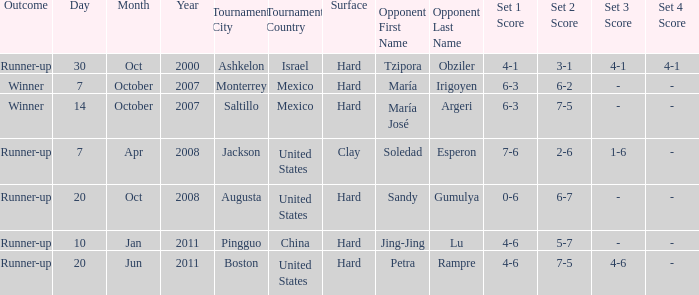What was the outcome when Jing-Jing Lu was the opponent? Runner-up. 